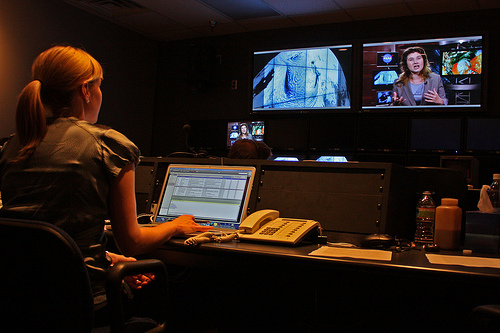How many women watching the TV? There is 1 woman in the image, who appears to be working at a video editing suite with multiple screens, rather than watching TV in a conventional sense. 